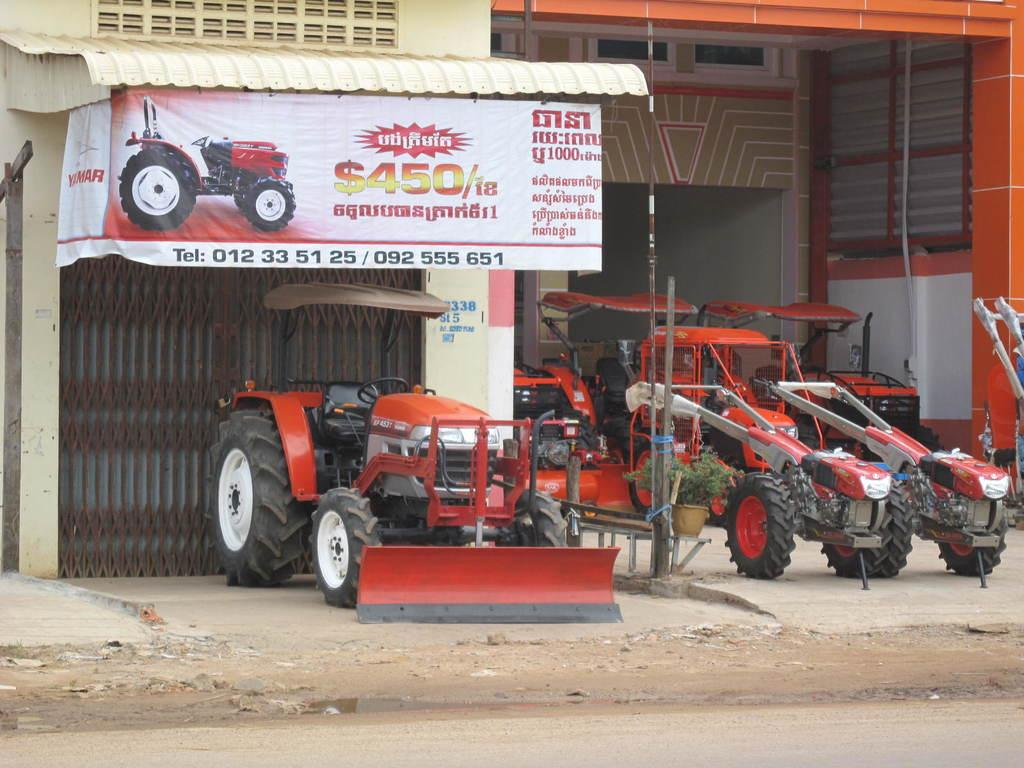What can be seen at the bottom of the image? There is a road, stones, and water visible at the bottom of the image. What type of vehicles are parked in the image? The facts do not specify the type of vehicles, but they are parked in the image. What is present in the background of the image? In the background of the image, there is a grill, walls, rods, a banner, and other objects. How does the knee spark in the image? There is no knee or spark present in the image. What type of rest can be seen in the image? There is no rest visible in the image; it features vehicles parked on a road with stones and water at the bottom, and various objects in the background. 